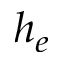Convert formula to latex. <formula><loc_0><loc_0><loc_500><loc_500>h _ { e }</formula> 